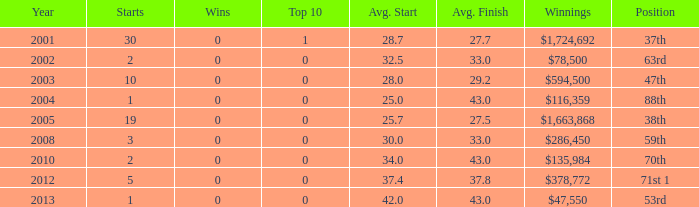How many starts for an average finish greater than 43? None. 